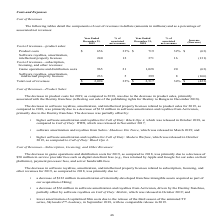According to Activision Blizzard's financial document, What were the product costs in 2019? According to the financial document, 656 (in millions). The relevant text states: "Product costs $ 656 33% $ 719 32% $ (63)..." Also, What were the game operations and distribution costs in 2019? According to the financial document, 965 (in millions). The relevant text states: "revenues: Game operations and distribution costs 965 21 1,028 20 (63)..." Also, What was the total cost of revenues in 2018? According to the financial document, 2,517 (in millions). The relevant text states: "Total cost of revenues $ 2,094 32% $ 2,517 34% $ (423)..." Also, can you calculate: What is the percentage change in product costs between 2018 and 2019? To answer this question, I need to perform calculations using the financial data. The calculation is: (656-719)/719, which equals -8.76 (percentage). This is based on the information: "Product costs $ 656 33% $ 719 32% $ (63) Product costs $ 656 33% $ 719 32% $ (63)..." The key data points involved are: 656, 719. Also, can you calculate: What is the percentage change in game operations and distribution costs between 2018 and 2019? To answer this question, I need to perform calculations using the financial data. The calculation is: (965-1,028)/1,028, which equals -6.13 (percentage). This is based on the information: "es: Game operations and distribution costs 965 21 1,028 20 (63) revenues: Game operations and distribution costs 965 21 1,028 20 (63)..." The key data points involved are: 1,028, 965. Also, can you calculate: What percentage of total cost of revenues in 2019 consists of product costs? Based on the calculation: (656/$2,094), the result is 31.33 (percentage). This is based on the information: "Total cost of revenues $ 2,094 32% $ 2,517 34% $ (423) Product costs $ 656 33% $ 719 32% $ (63)..." The key data points involved are: 2,094, 656. 